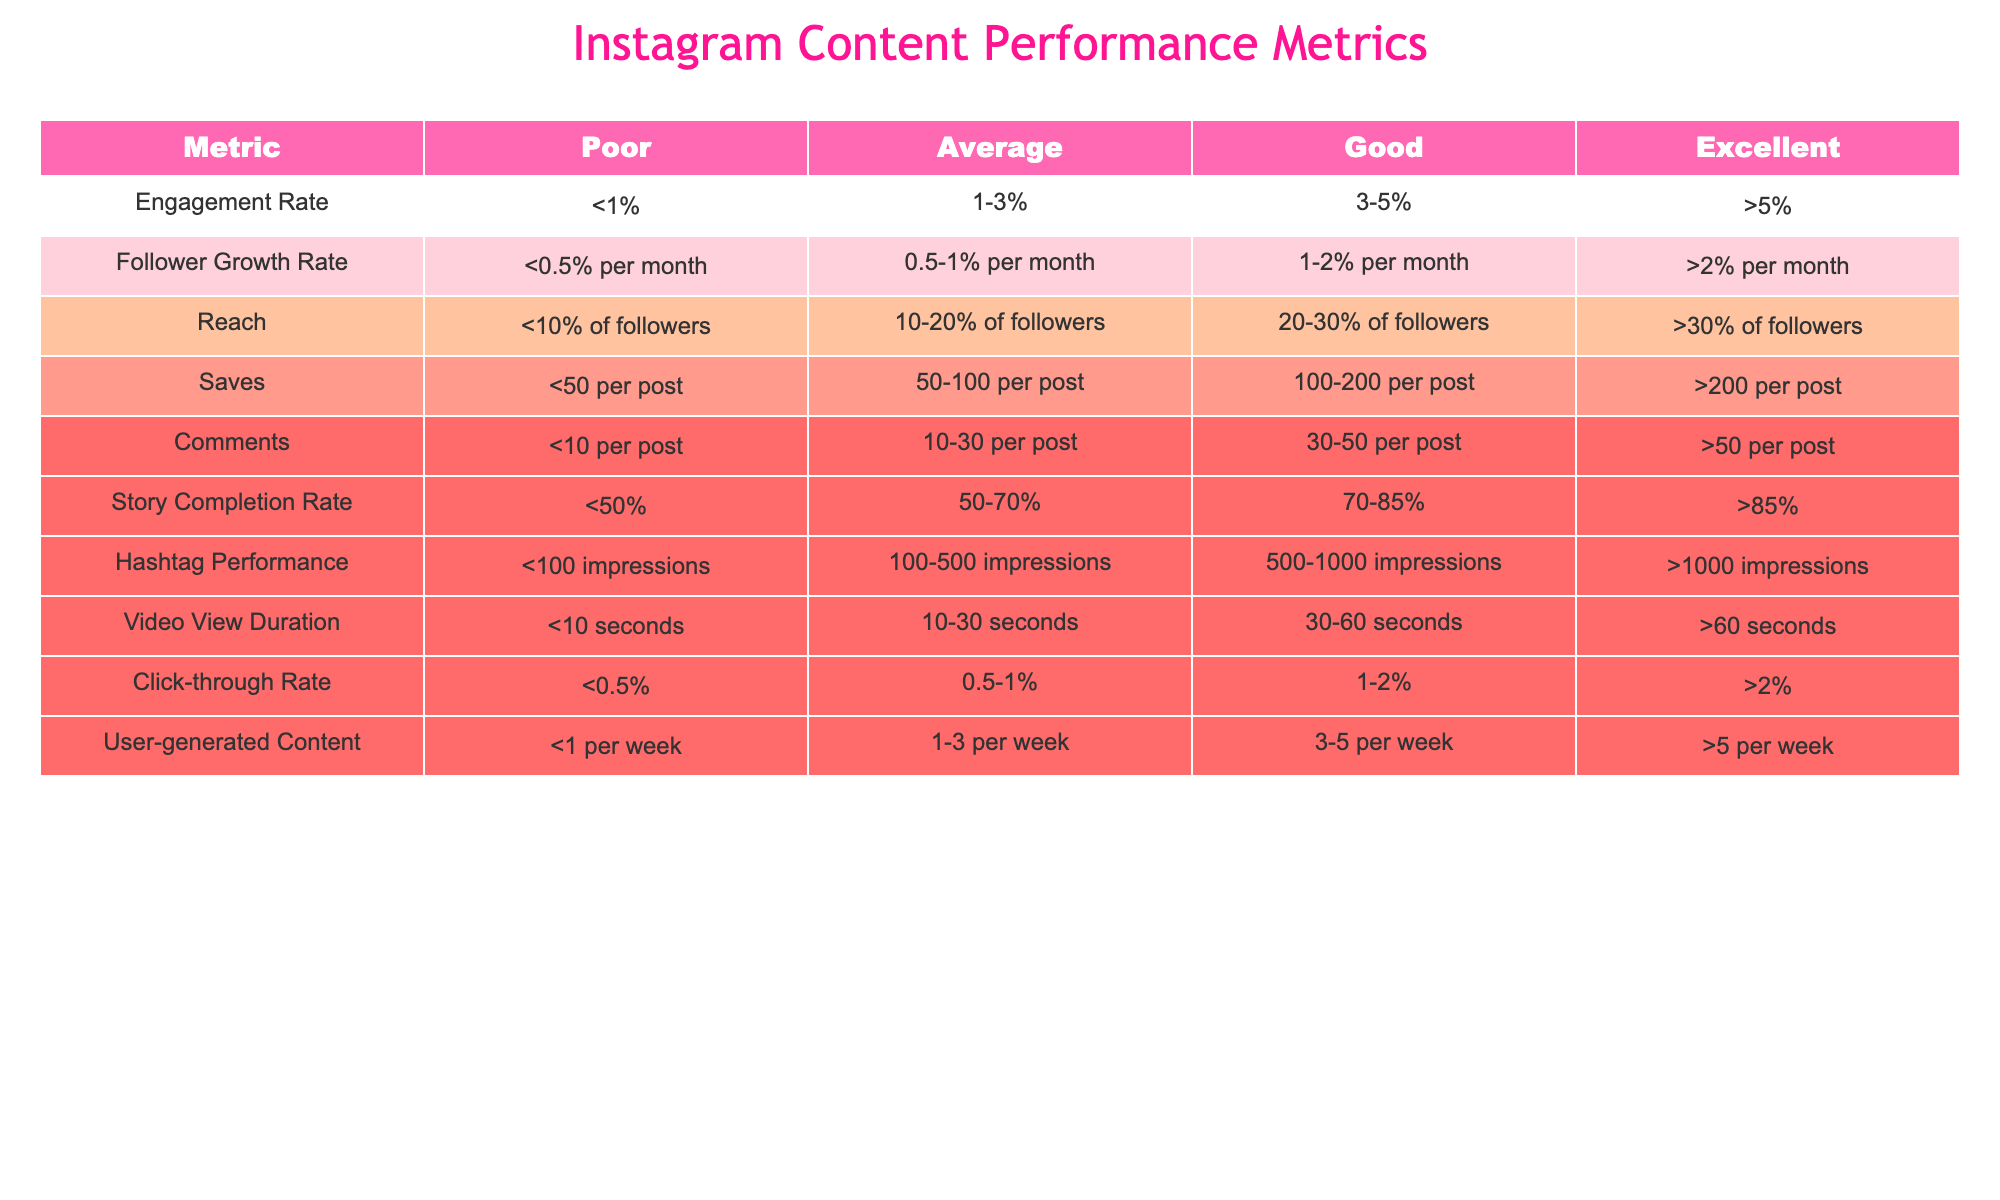What is the engagement rate range for a "Good" performance? The table lists "Good" performance under engagement rate as ranging from 3-5%.
Answer: 3-5% What are the criteria for "Excellent" follower growth rate? The table defines "Excellent" follower growth rate as being greater than 2% per month.
Answer: >2% per month Is a story completion rate of 60% considered "Average"? According to the table, an average story completion rate falls between 50-70%, so 60% fits within this range.
Answer: Yes What is the difference in saves required to move from "Average" to "Good" performance? In the table, "Average" saves are 50-100 per post, while "Good" saves are 100-200 per post. The difference between the lower bounds is 100 - 50 = 50 saves.
Answer: 50 saves How many user-generated posts are needed to achieve a "Poor" performance rating? The table specifies that a "Poor" performance in user-generated content is less than 1 post per week.
Answer: <1 per week What is the average reach percentage for "Good" and "Excellent" categories combined? "Good" reach is 20-30% and "Excellent" reach is over 30%. To find an average, we can consider the median of 25% for "Good" and approximate at 35% for "Excellent" (though actual data may vary), leading to an average of (25 + 35) / 2 = 30%.
Answer: 30% Is the video view duration of 50 seconds sufficient for a "Good" performance rating? 50 seconds does not meet the "Good" video view duration requirement which is 30-60 seconds; it's at the upper limit, so it is just enough to classify as "Good."
Answer: Yes How many comments are considered "Excellent" performance? The table illustrates that "Excellent" performance for comments is more than 50 per post.
Answer: >50 per post What percentage of followers is considered "Poor" reach? According to the table, "Poor" reach is defined as less than 10% of followers.
Answer: <10% of followers 